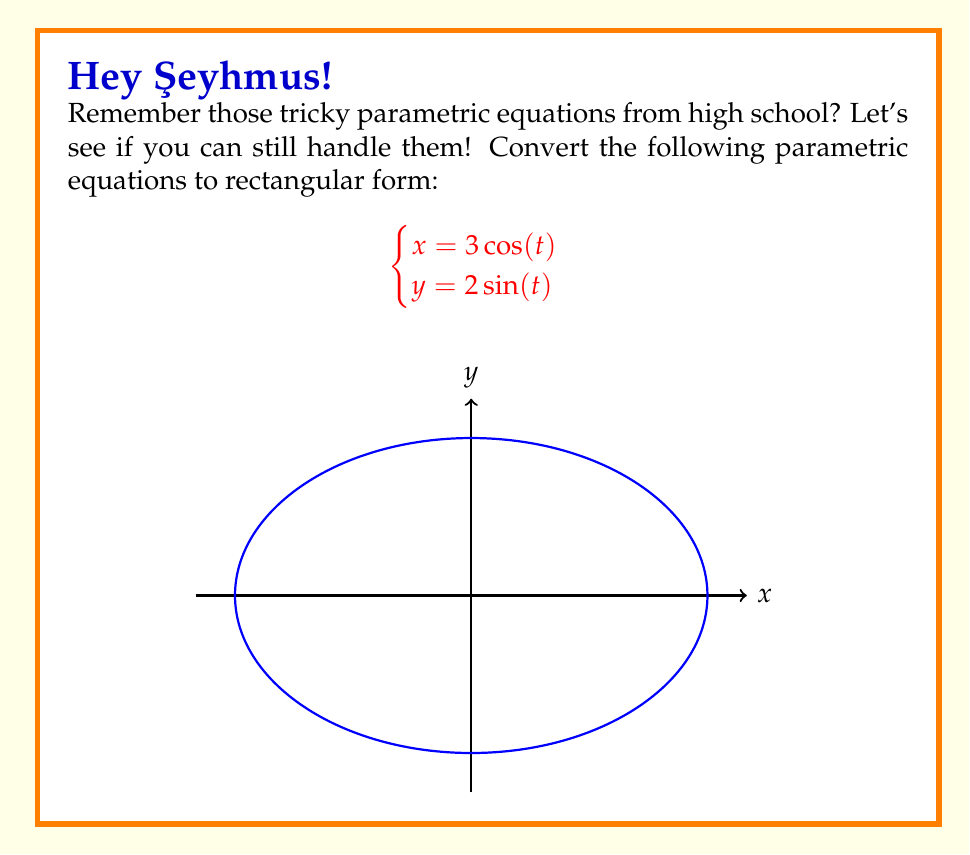Provide a solution to this math problem. Let's approach this step-by-step:

1) To eliminate the parameter $t$, we need to find a relationship between $x$ and $y$ that doesn't involve $t$.

2) From the first equation, we can express $\cos(t)$ in terms of $x$:
   $$\cos(t) = \frac{x}{3}$$

3) From the second equation, we can express $\sin(t)$ in terms of $y$:
   $$\sin(t) = \frac{y}{2}$$

4) We know that for any angle $t$, $\sin^2(t) + \cos^2(t) = 1$. Let's use this identity:
   $$\left(\frac{y}{2}\right)^2 + \left(\frac{x}{3}\right)^2 = 1$$

5) Let's simplify this equation:
   $$\frac{y^2}{4} + \frac{x^2}{9} = 1$$

6) Multiply both sides by 36 to eliminate fractions:
   $$9y^2 + 4x^2 = 36$$

This is the equation of an ellipse centered at the origin, with a horizontal semi-major axis of 3 and a vertical semi-minor axis of 2, which matches the graph provided in the question.
Answer: $$\frac{x^2}{9} + \frac{y^2}{4} = 1$$ 